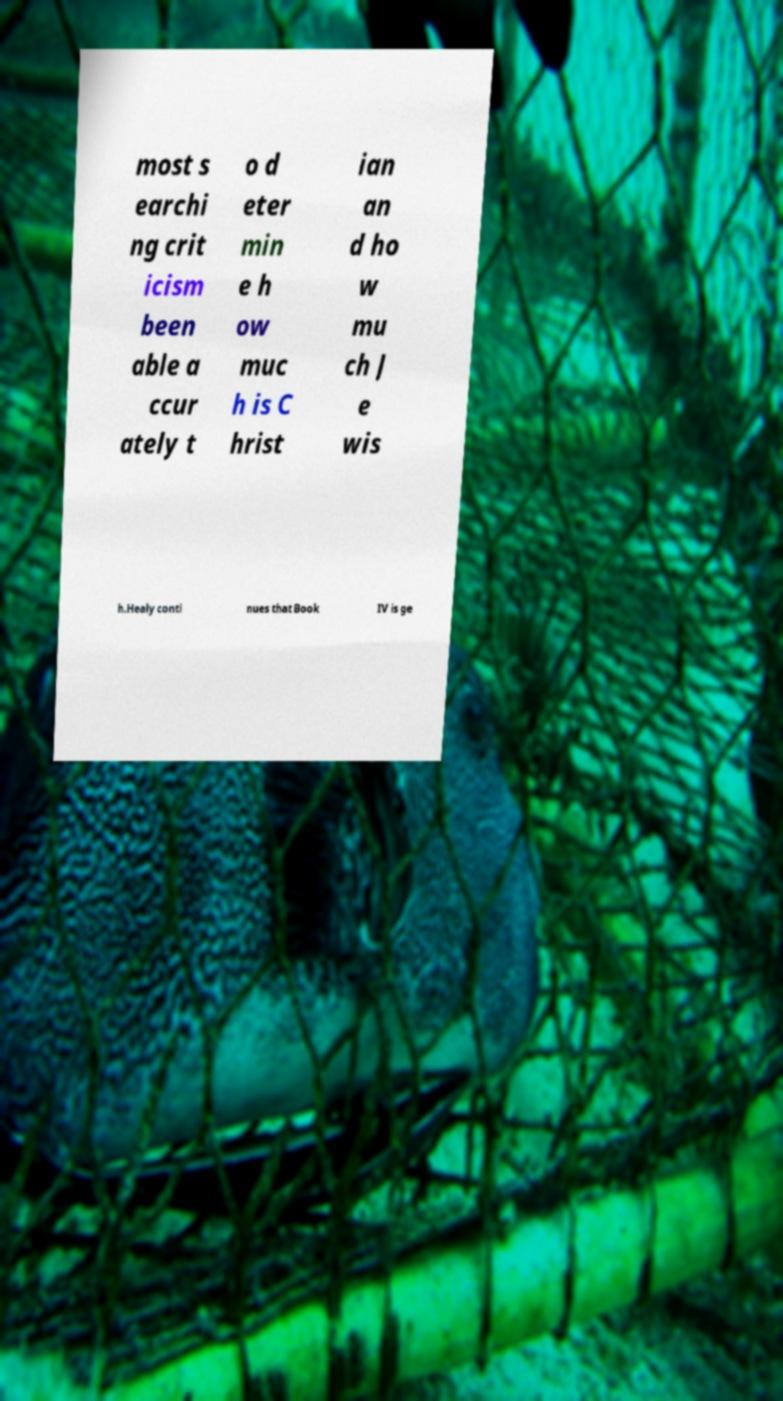Please identify and transcribe the text found in this image. most s earchi ng crit icism been able a ccur ately t o d eter min e h ow muc h is C hrist ian an d ho w mu ch J e wis h.Healy conti nues that Book IV is ge 